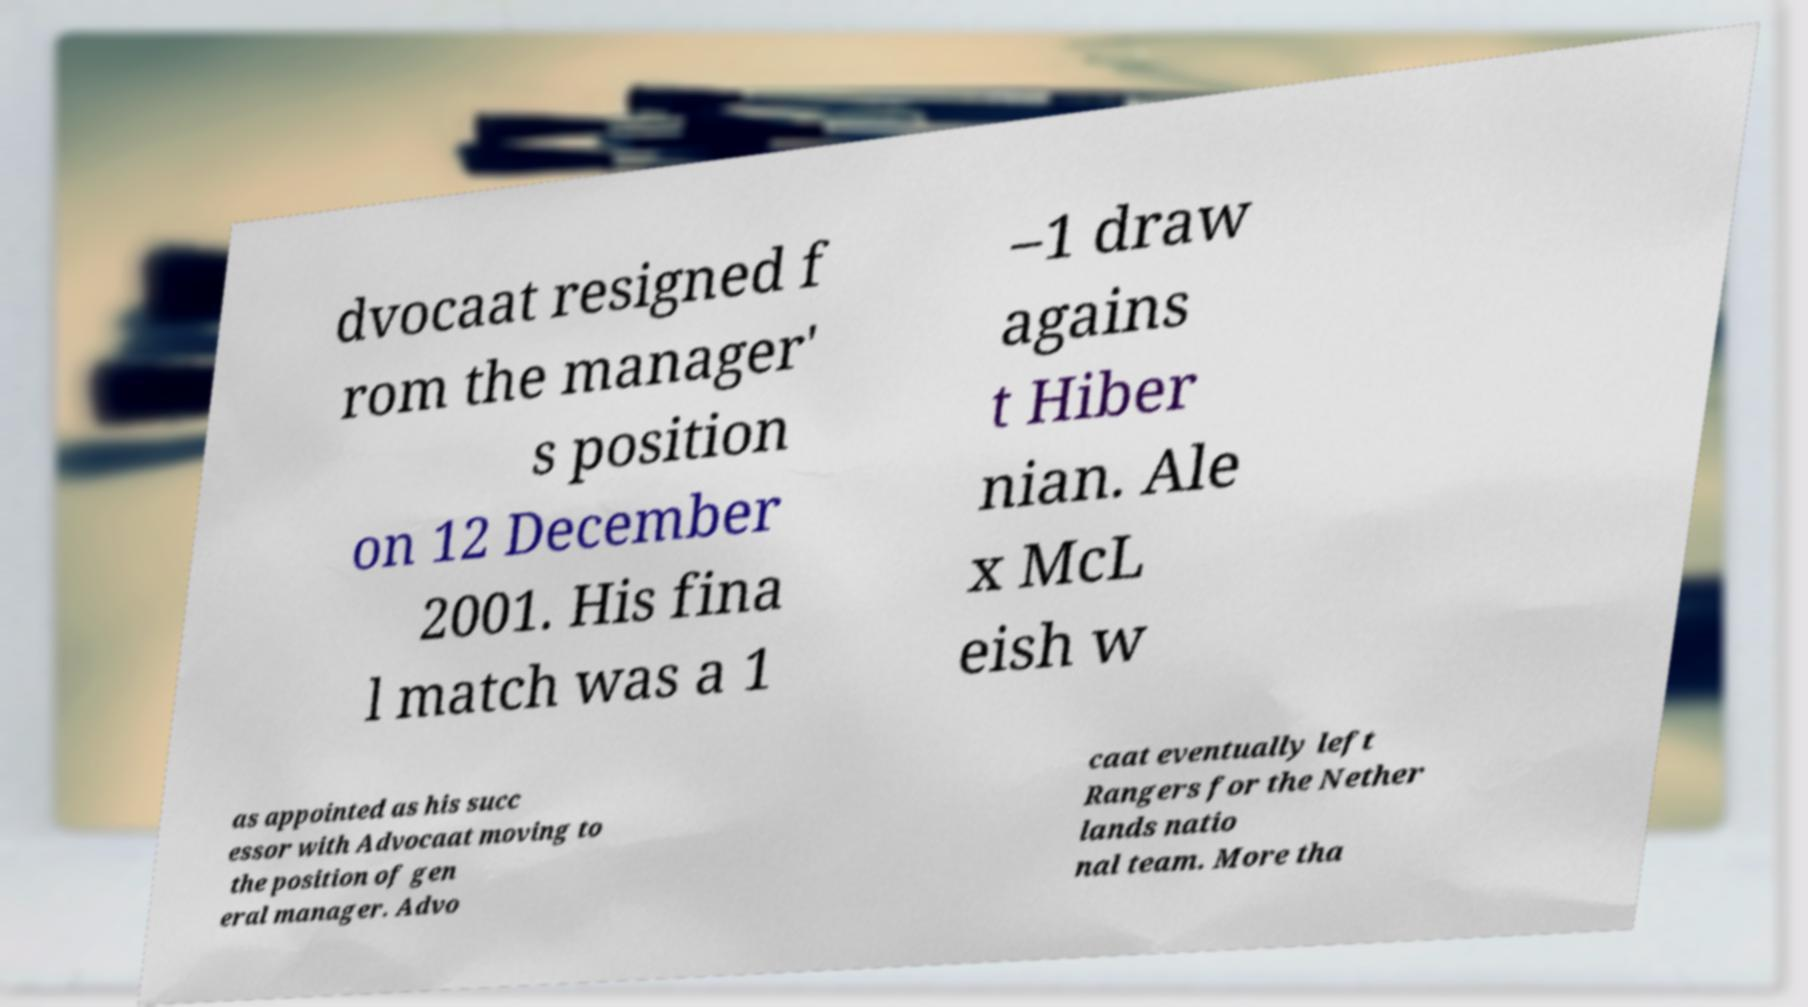Please read and relay the text visible in this image. What does it say? dvocaat resigned f rom the manager' s position on 12 December 2001. His fina l match was a 1 –1 draw agains t Hiber nian. Ale x McL eish w as appointed as his succ essor with Advocaat moving to the position of gen eral manager. Advo caat eventually left Rangers for the Nether lands natio nal team. More tha 